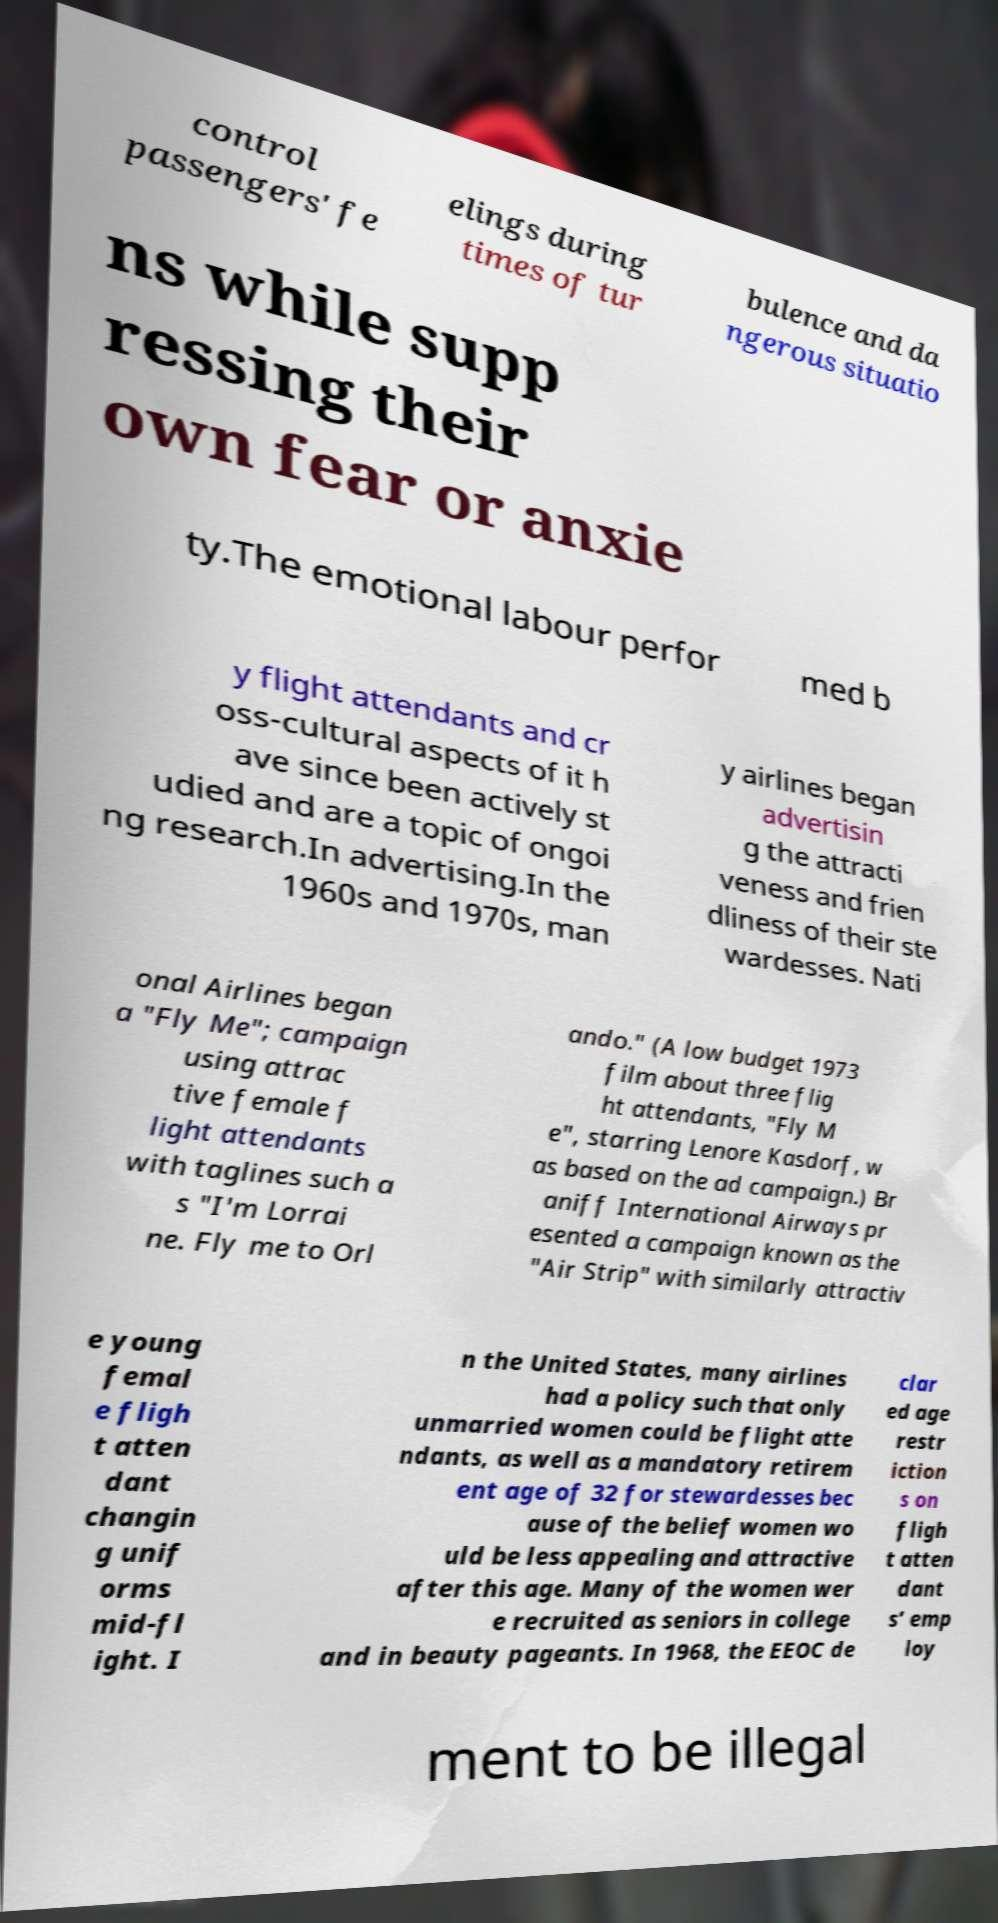Can you read and provide the text displayed in the image?This photo seems to have some interesting text. Can you extract and type it out for me? control passengers' fe elings during times of tur bulence and da ngerous situatio ns while supp ressing their own fear or anxie ty.The emotional labour perfor med b y flight attendants and cr oss-cultural aspects of it h ave since been actively st udied and are a topic of ongoi ng research.In advertising.In the 1960s and 1970s, man y airlines began advertisin g the attracti veness and frien dliness of their ste wardesses. Nati onal Airlines began a "Fly Me"; campaign using attrac tive female f light attendants with taglines such a s "I'm Lorrai ne. Fly me to Orl ando." (A low budget 1973 film about three flig ht attendants, "Fly M e", starring Lenore Kasdorf, w as based on the ad campaign.) Br aniff International Airways pr esented a campaign known as the "Air Strip" with similarly attractiv e young femal e fligh t atten dant changin g unif orms mid-fl ight. I n the United States, many airlines had a policy such that only unmarried women could be flight atte ndants, as well as a mandatory retirem ent age of 32 for stewardesses bec ause of the belief women wo uld be less appealing and attractive after this age. Many of the women wer e recruited as seniors in college and in beauty pageants. In 1968, the EEOC de clar ed age restr iction s on fligh t atten dant s’ emp loy ment to be illegal 